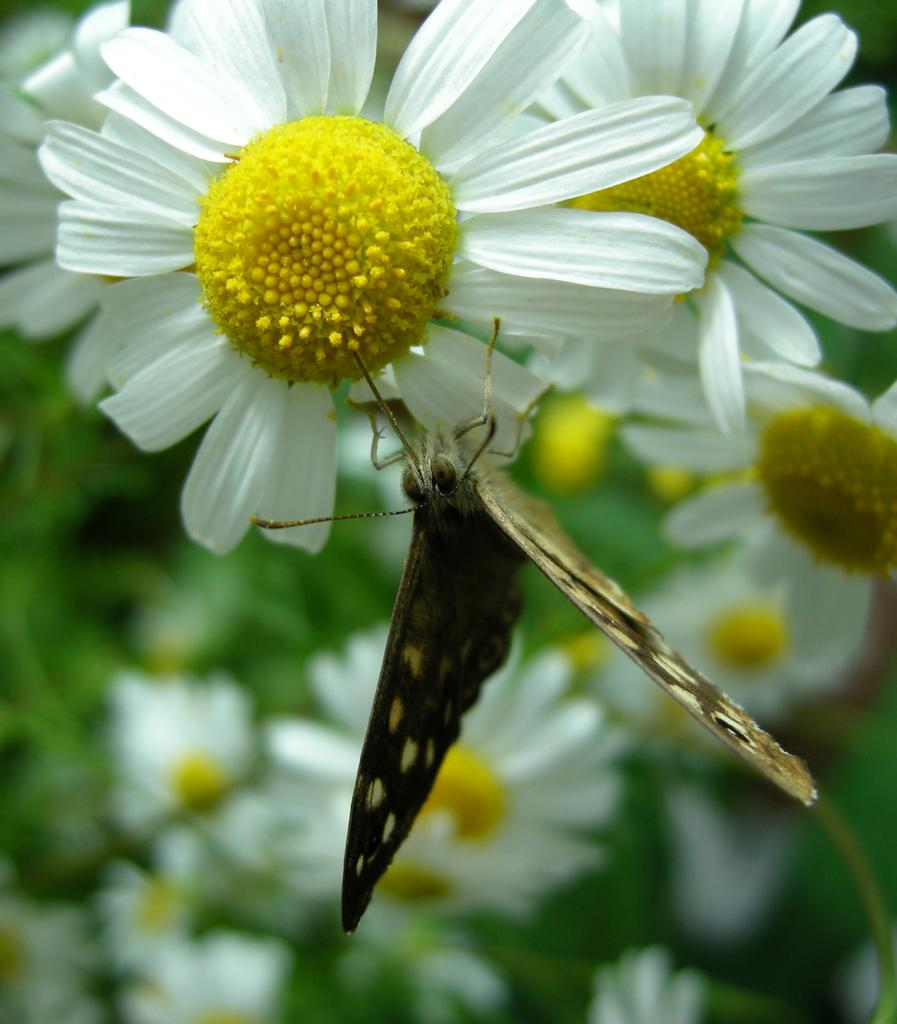What is the main subject of the image? There is a butterfly in the image. Where is the butterfly located in the image? The butterfly is sitting on a flower. Can you describe the flower the butterfly is on? The flower has white and yellow colors. How many flowers can be seen in the image? There are many flowers visible in the image. Can you hear the tree laughing in the image? There is no tree or laughter present in the image; it features a butterfly sitting on a flower. How many cents are visible on the flower in the image? There are no cents present on the flower or in the image. 